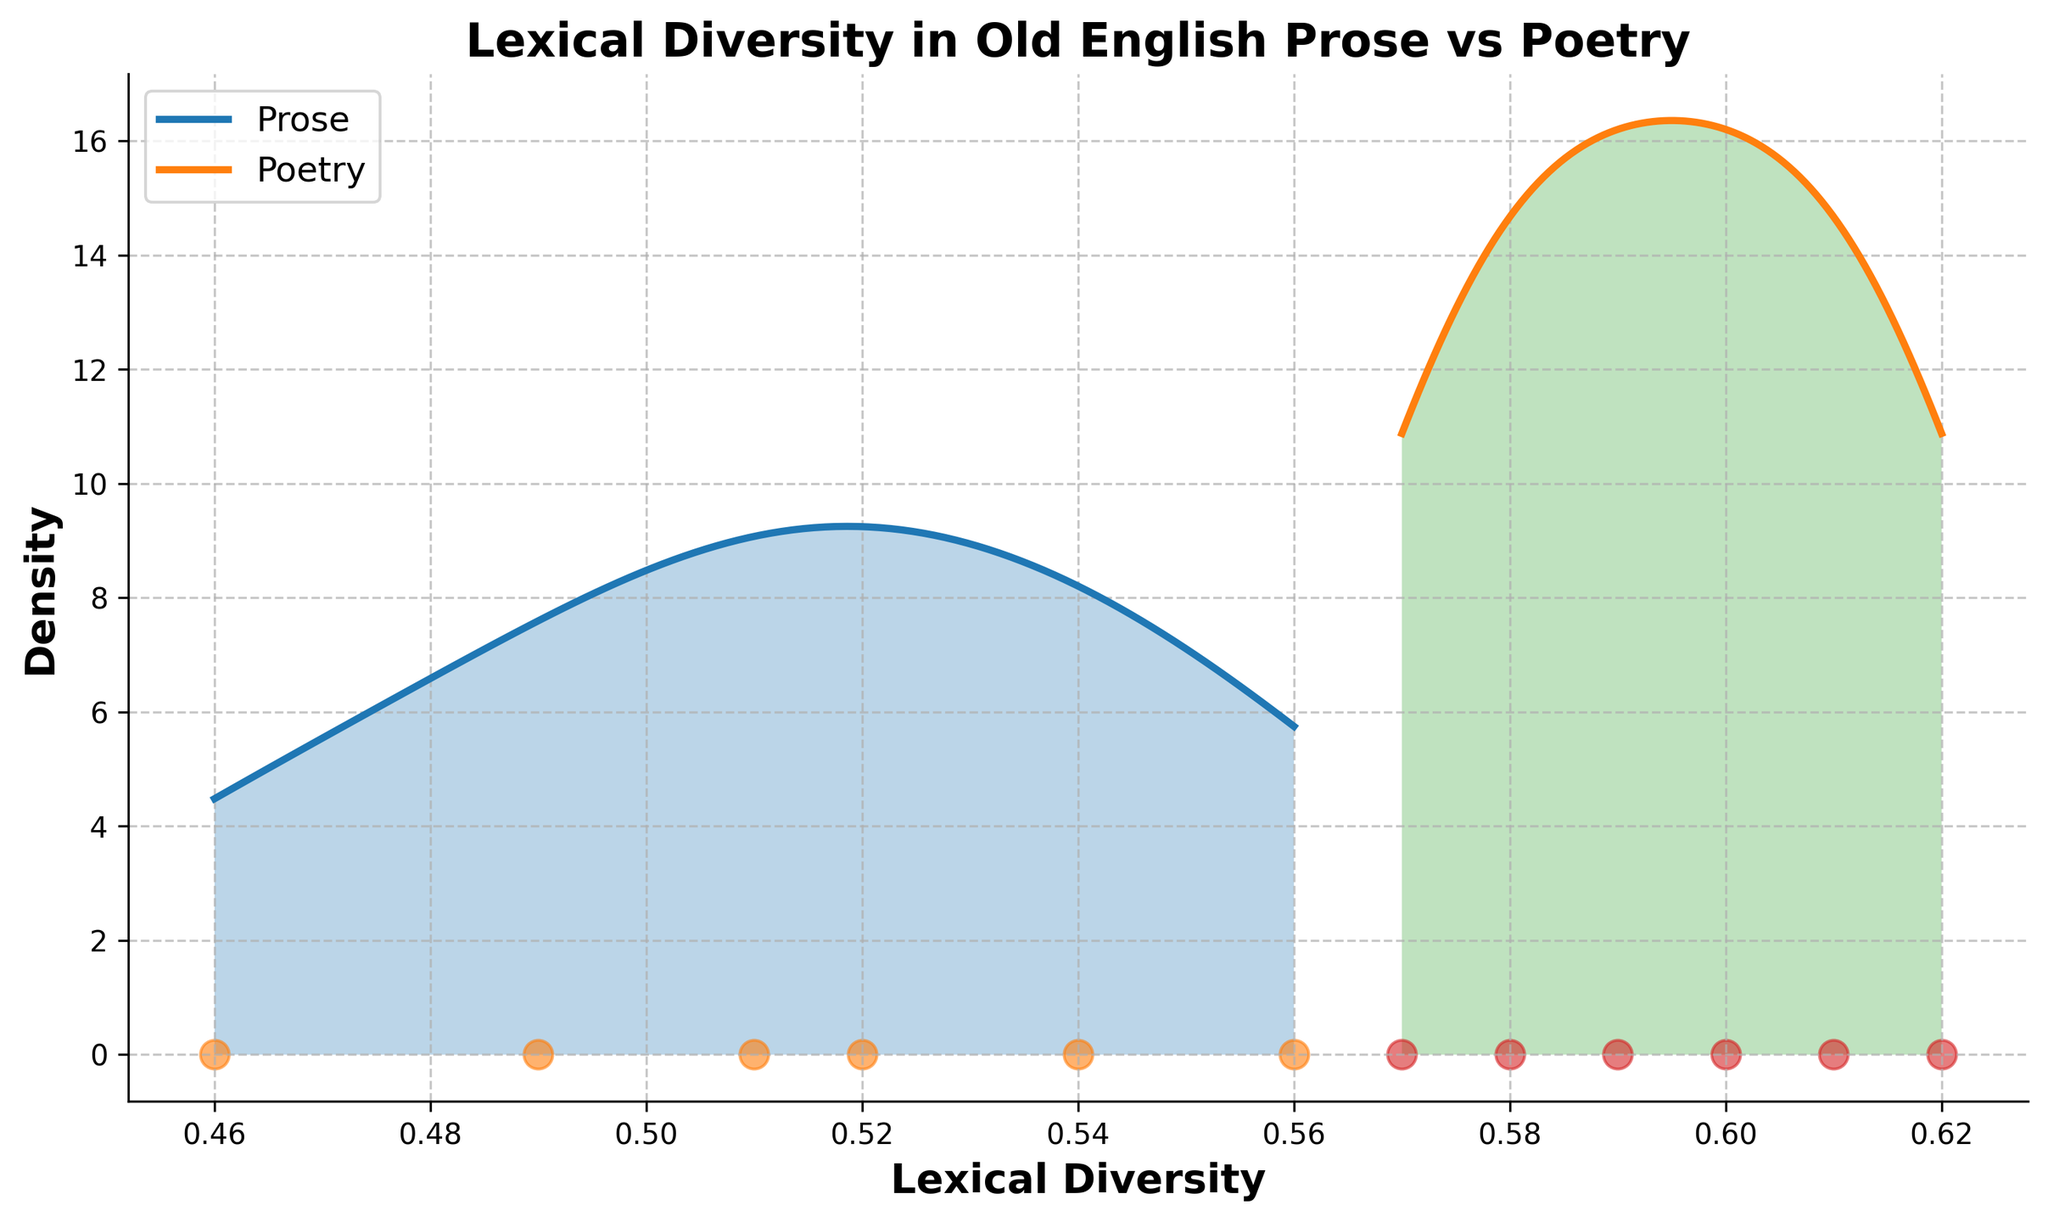What is the title of the figure? The title is usually found at the top of the figure. It provides a concise summary of what the figure represents.
Answer: Lexical Diversity in Old English Prose vs Poetry How many categories are represented in the figure? To determine the number of categories, look at the legend which usually lists them.
Answer: 2 Which text type has a higher overall peak density in lexical diversity? Observe the peak of the curves for each text type and compare their heights.
Answer: Poetry What is the approximate lexical diversity value where the prose density is highest? Find the peak point of the prose density curve on the horizontal axis.
Answer: 0.51 Which text type shows a wider spread in lexical diversity values? Compare the range of values on the horizontal axis for both prose and poetry.
Answer: Poetry What is the range of lexical diversity values for poetry? Identify the minimum and maximum values of the lexical diversity for poetry on the horizontal axis.
Answer: 0.57 to 0.62 How does the lexical diversity of "Beowulf" differ between its prose and poetry versions? Locate the lexical diversity values for both prose and poetry versions of "Beowulf" and compare them.
Answer: Poetry Beowulf is higher Which text type shows the lowest lexical diversity value and what is it? Identify the lowest point on the horizontal axis from the scatter points and determine which text type it belongs to.
Answer: Prose, 0.46 Does prose or poetry have more data points in the figure? Count the number of scatter points for both prose and poetry.
Answer: Poetry Which text type occupies a greater density region around 0.60 in the lexical diversity scale? Observe the density curves close to the 0.60 mark on the horizontal axis for both text types.
Answer: Poetry 